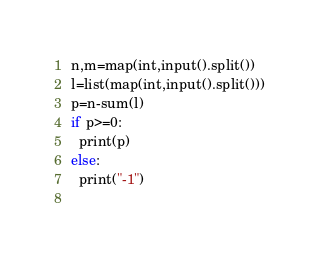Convert code to text. <code><loc_0><loc_0><loc_500><loc_500><_Python_>n,m=map(int,input().split())
l=list(map(int,input().split()))
p=n-sum(l)
if p>=0:
  print(p)
else:
  print("-1")
       </code> 